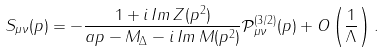Convert formula to latex. <formula><loc_0><loc_0><loc_500><loc_500>S _ { \mu \nu } ( p ) = - \frac { 1 + i \, I m \, Z ( p ^ { 2 } ) } { \sl a p - M _ { \Delta } - i \, I m \, M ( p ^ { 2 } ) } { \mathcal { P } } ^ { ( 3 / 2 ) } _ { \mu \nu } ( p ) + O \left ( \frac { 1 } { \Lambda } \right ) .</formula> 